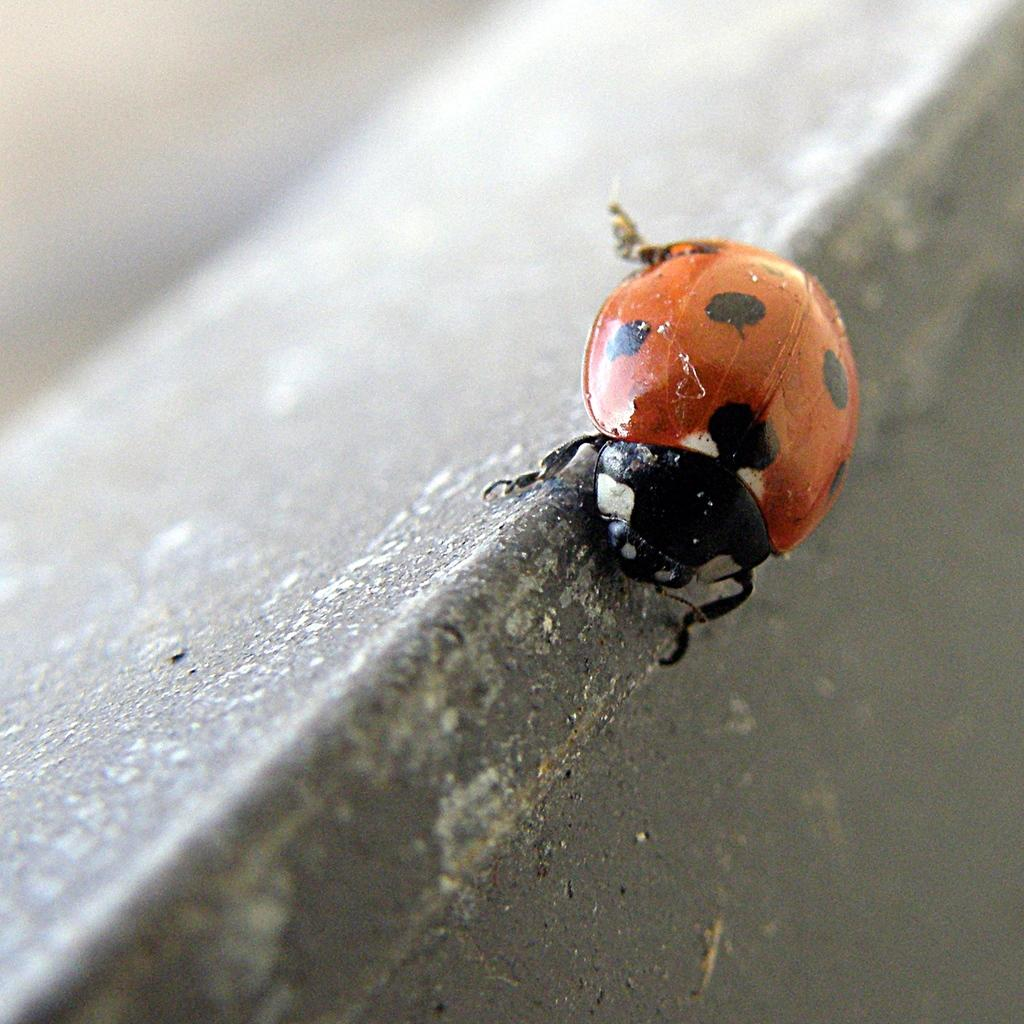What type of insect is in the image? There is a ladybird beetle in the image. Can you describe the background of the image? The background of the image is blurry. What type of stew is being prepared in the image? There is no stew present in the image; it features a ladybird beetle with a blurry background. 